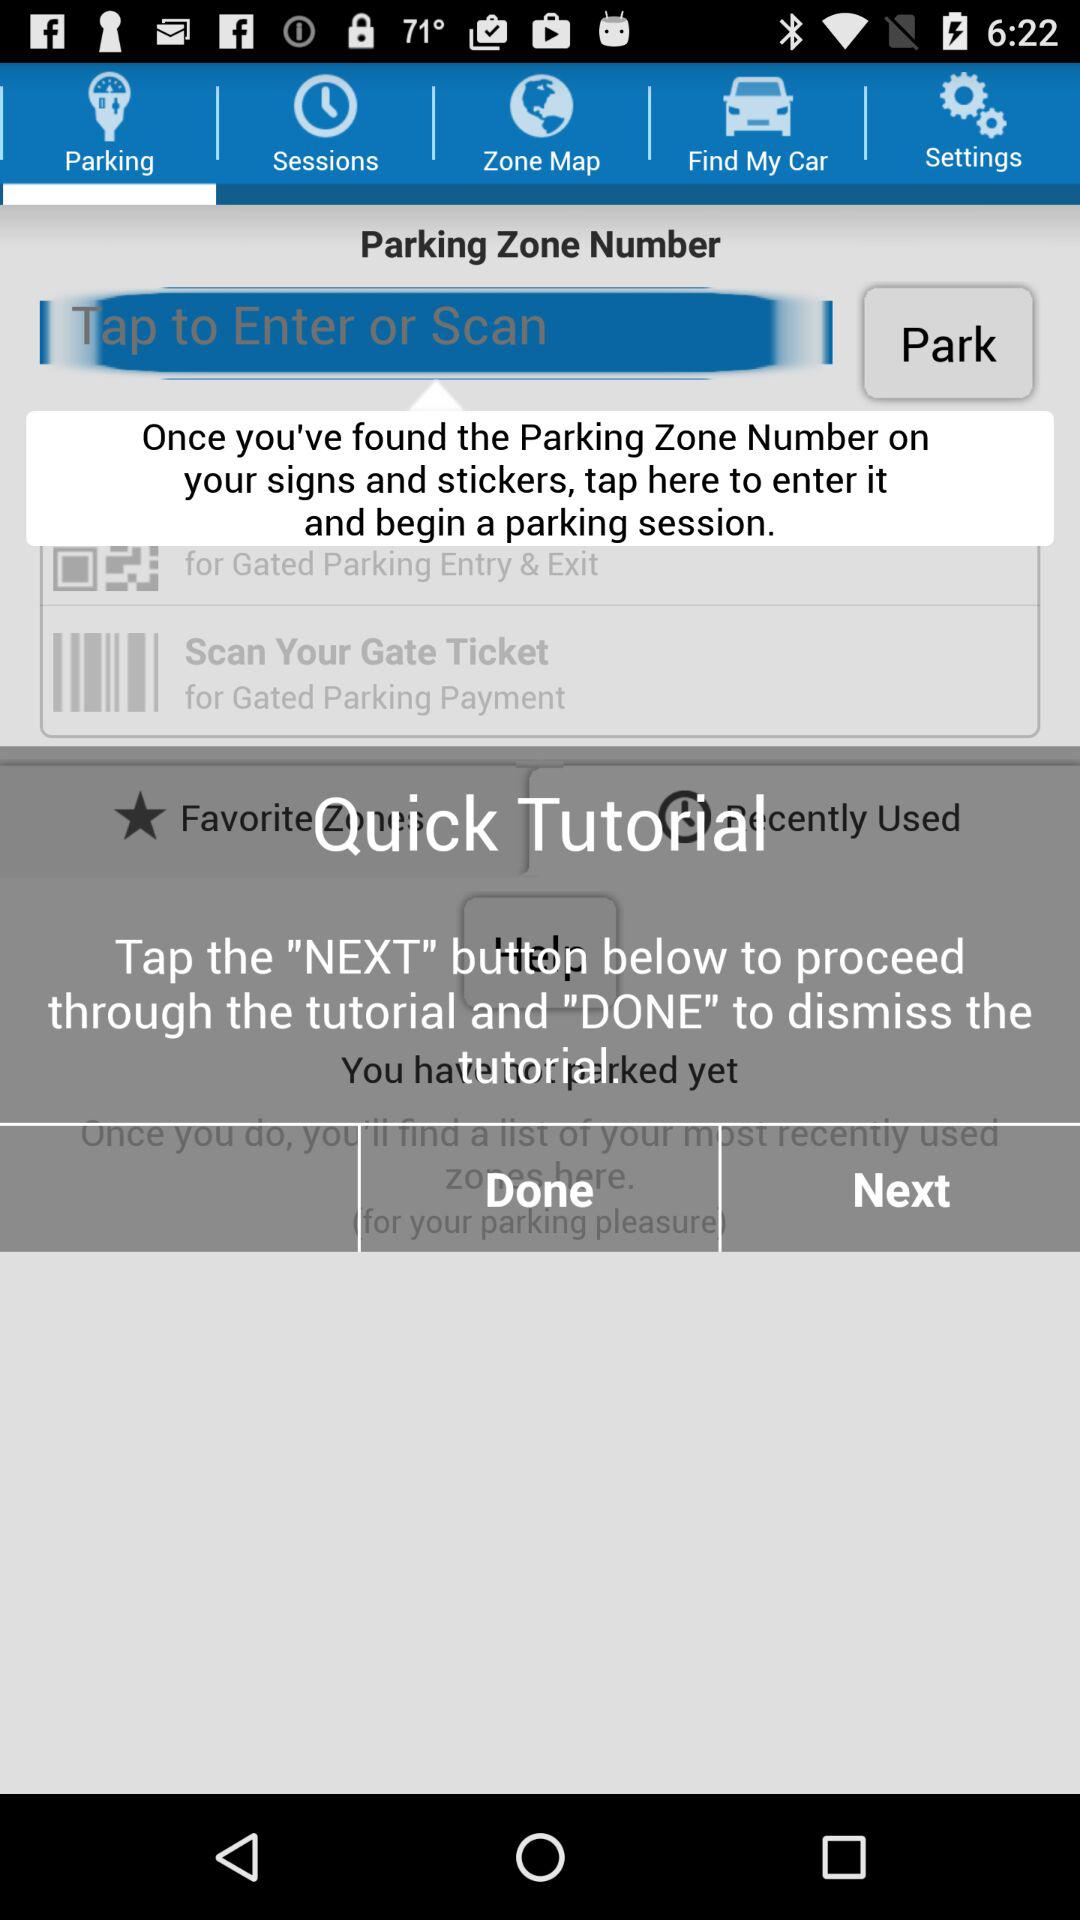Why do we use the "DONE" button? You use the "DONE" button to dismiss the tutorial. 